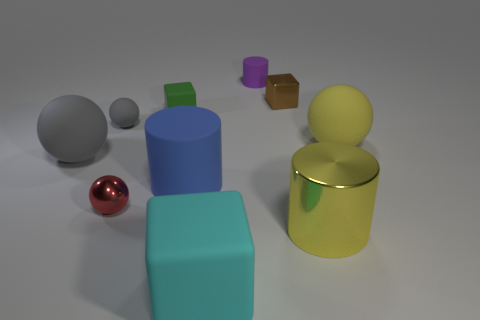Subtract all brown metallic blocks. How many blocks are left? 2 Subtract all purple cylinders. How many cylinders are left? 2 Subtract 1 blocks. How many blocks are left? 2 Add 4 yellow cylinders. How many yellow cylinders are left? 5 Add 3 tiny red things. How many tiny red things exist? 4 Subtract 0 brown spheres. How many objects are left? 10 Subtract all cubes. How many objects are left? 7 Subtract all brown cylinders. Subtract all green spheres. How many cylinders are left? 3 Subtract all yellow spheres. How many yellow cylinders are left? 1 Subtract all small shiny blocks. Subtract all small red balls. How many objects are left? 8 